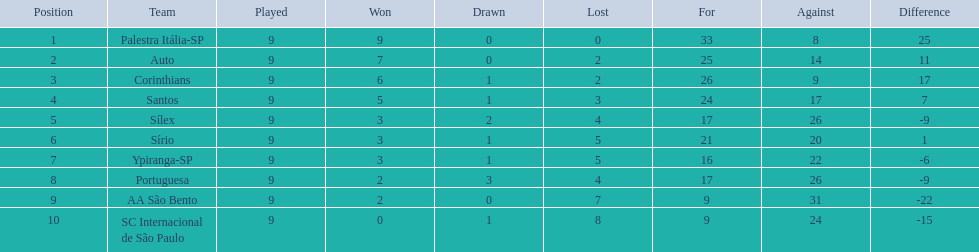What teams played in 1926? Palestra Itália-SP, Auto, Corinthians, Santos, Sílex, Sírio, Ypiranga-SP, Portuguesa, AA São Bento, SC Internacional de São Paulo. Did any team lose zero games? Palestra Itália-SP. 